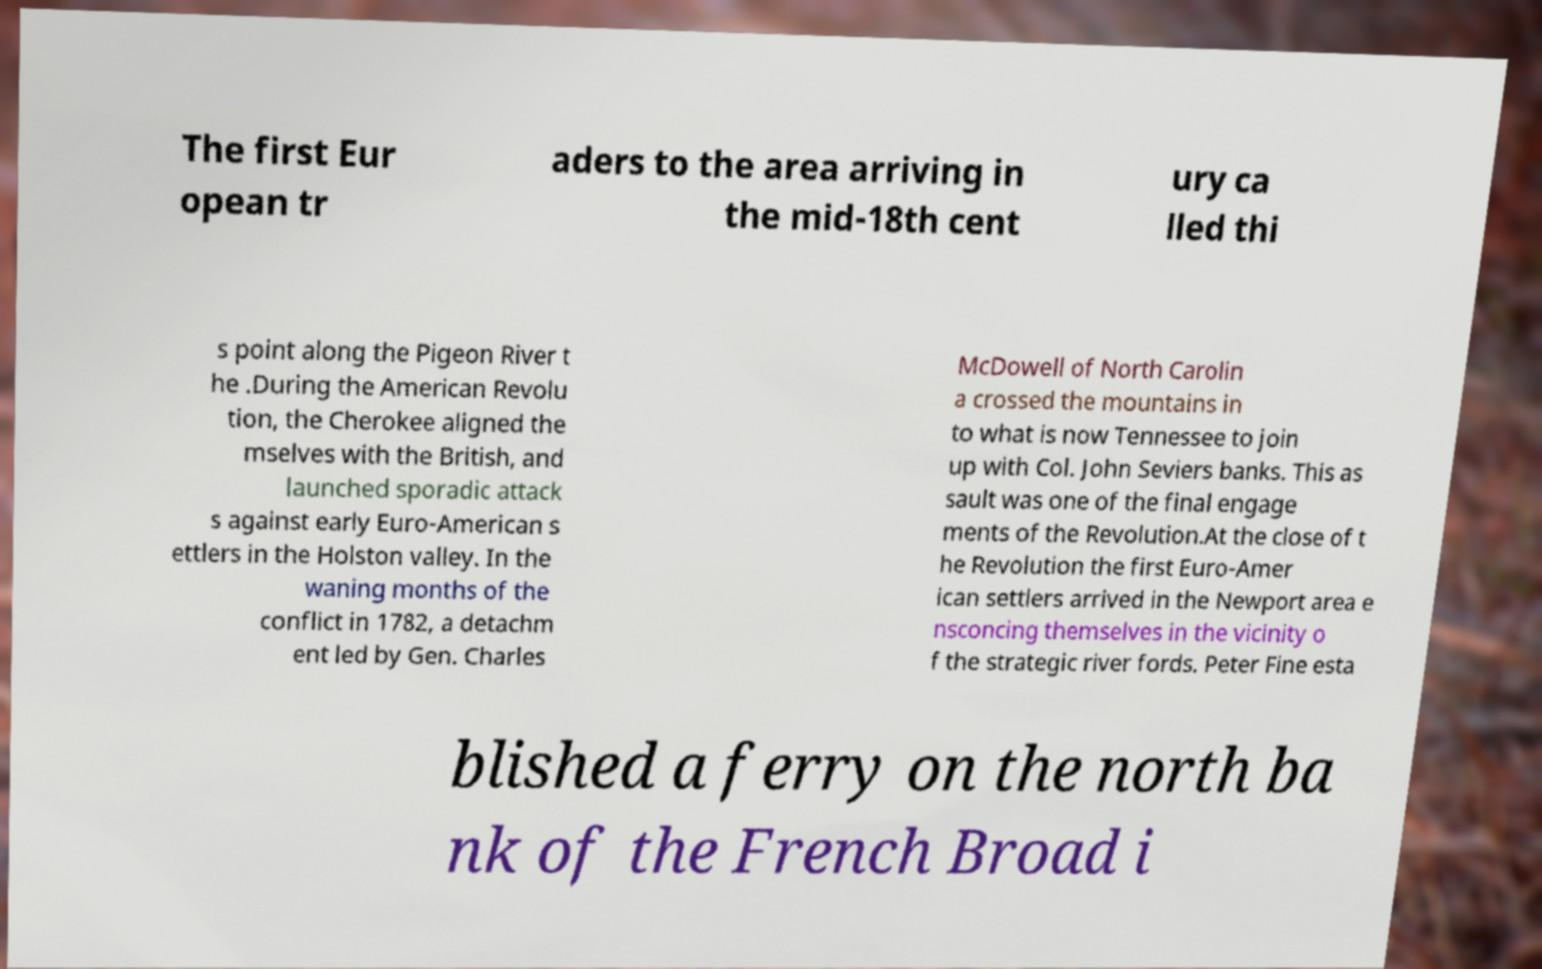Could you assist in decoding the text presented in this image and type it out clearly? The first Eur opean tr aders to the area arriving in the mid-18th cent ury ca lled thi s point along the Pigeon River t he .During the American Revolu tion, the Cherokee aligned the mselves with the British, and launched sporadic attack s against early Euro-American s ettlers in the Holston valley. In the waning months of the conflict in 1782, a detachm ent led by Gen. Charles McDowell of North Carolin a crossed the mountains in to what is now Tennessee to join up with Col. John Seviers banks. This as sault was one of the final engage ments of the Revolution.At the close of t he Revolution the first Euro-Amer ican settlers arrived in the Newport area e nsconcing themselves in the vicinity o f the strategic river fords. Peter Fine esta blished a ferry on the north ba nk of the French Broad i 